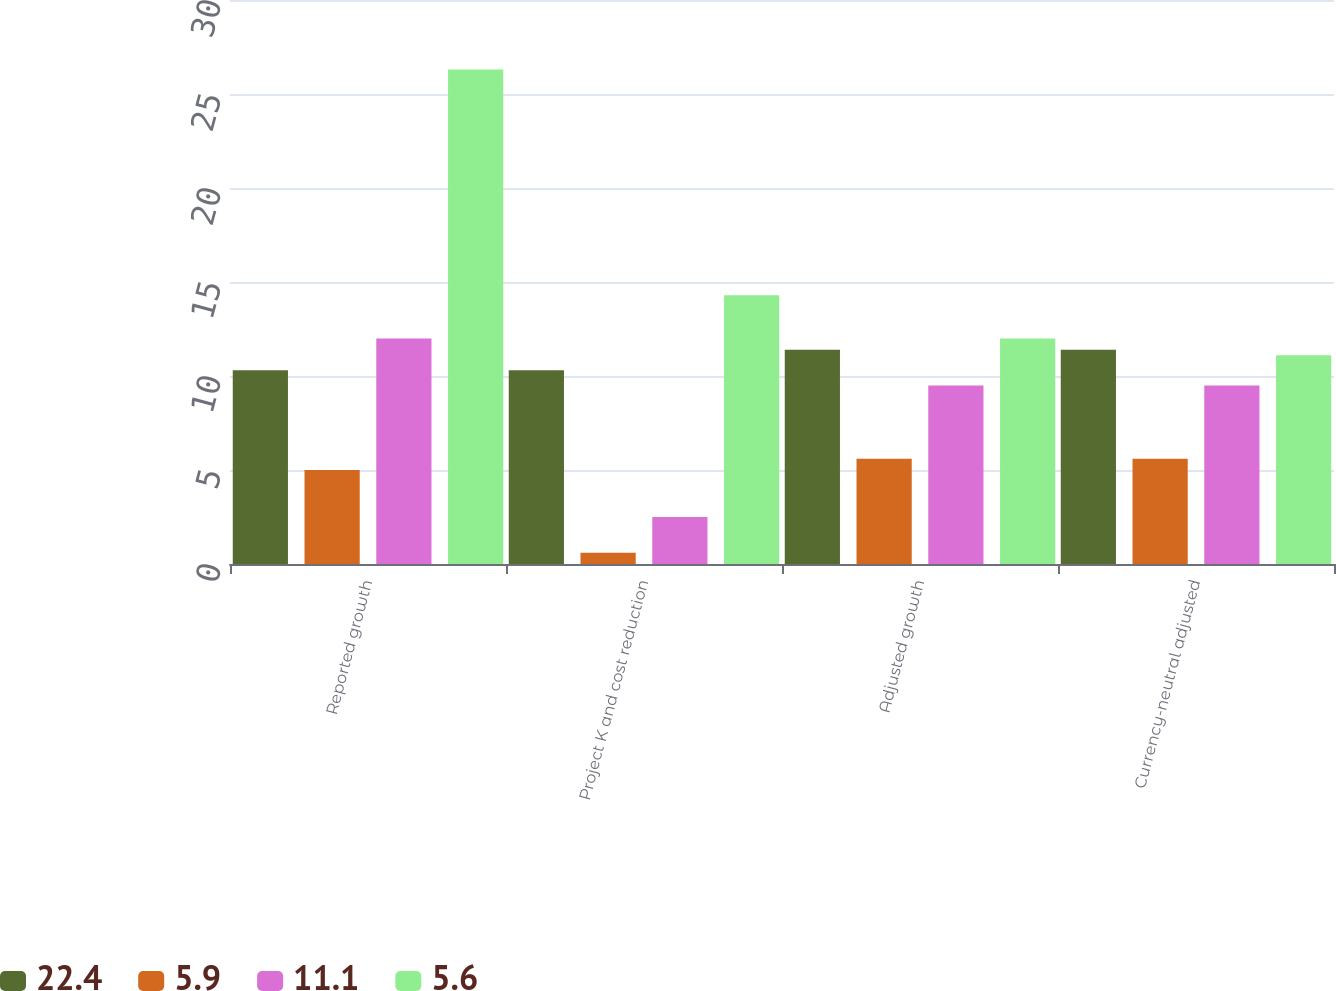Convert chart to OTSL. <chart><loc_0><loc_0><loc_500><loc_500><stacked_bar_chart><ecel><fcel>Reported growth<fcel>Project K and cost reduction<fcel>Adjusted growth<fcel>Currency-neutral adjusted<nl><fcel>22.4<fcel>10.3<fcel>10.3<fcel>11.4<fcel>11.4<nl><fcel>5.9<fcel>5<fcel>0.6<fcel>5.6<fcel>5.6<nl><fcel>11.1<fcel>12<fcel>2.5<fcel>9.5<fcel>9.5<nl><fcel>5.6<fcel>26.3<fcel>14.3<fcel>12<fcel>11.1<nl></chart> 